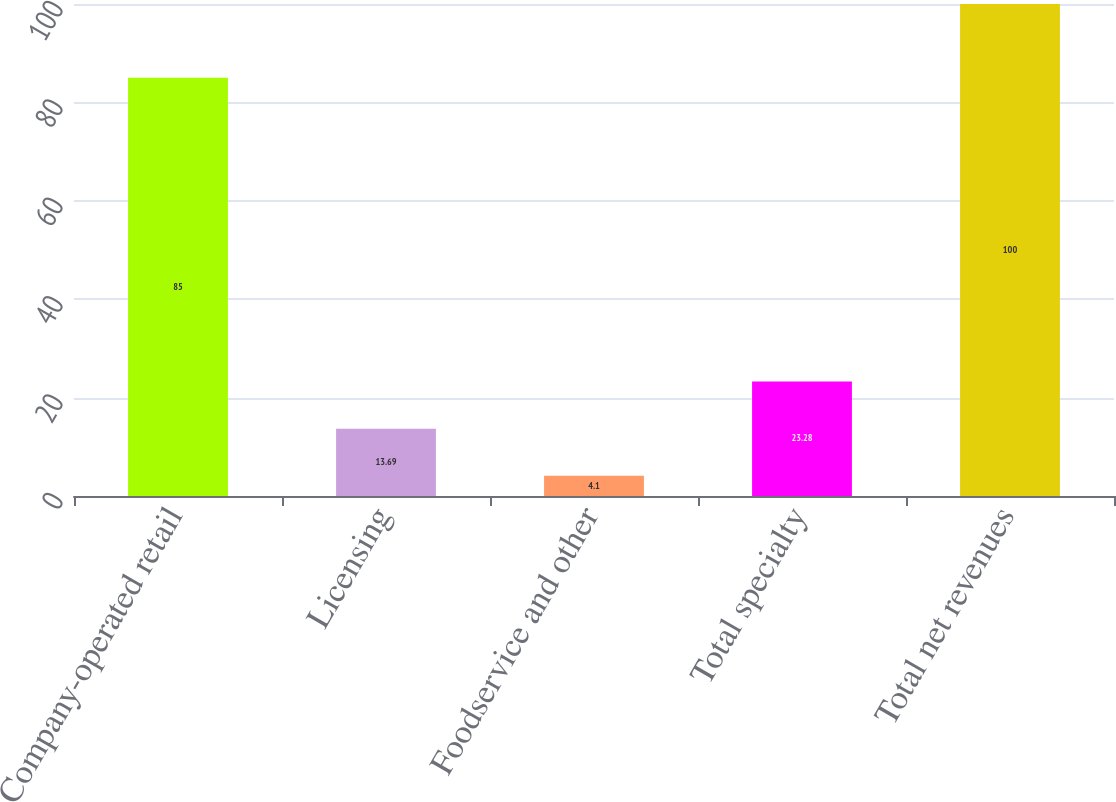Convert chart. <chart><loc_0><loc_0><loc_500><loc_500><bar_chart><fcel>Company-operated retail<fcel>Licensing<fcel>Foodservice and other<fcel>Total specialty<fcel>Total net revenues<nl><fcel>85<fcel>13.69<fcel>4.1<fcel>23.28<fcel>100<nl></chart> 